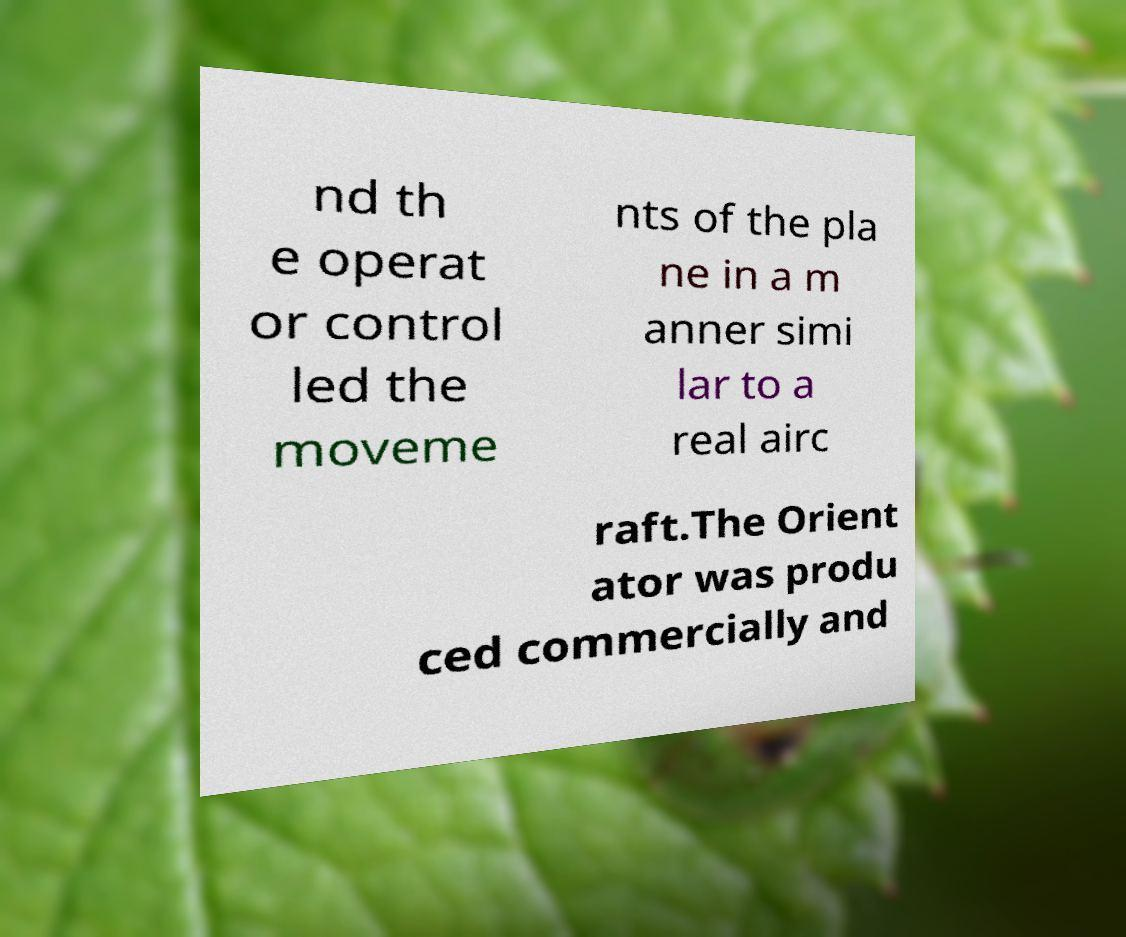I need the written content from this picture converted into text. Can you do that? nd th e operat or control led the moveme nts of the pla ne in a m anner simi lar to a real airc raft.The Orient ator was produ ced commercially and 